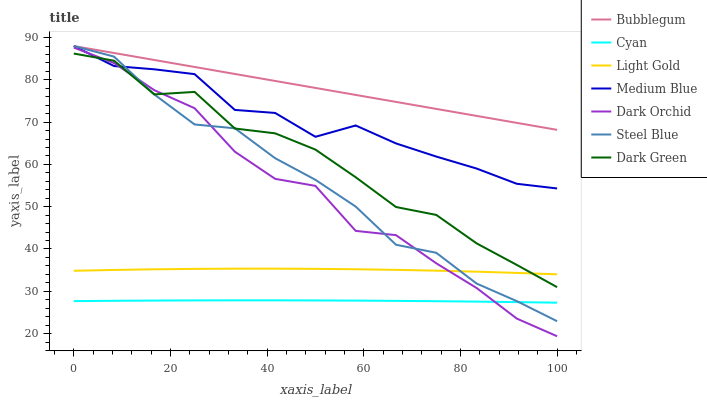Does Cyan have the minimum area under the curve?
Answer yes or no. Yes. Does Bubblegum have the maximum area under the curve?
Answer yes or no. Yes. Does Steel Blue have the minimum area under the curve?
Answer yes or no. No. Does Steel Blue have the maximum area under the curve?
Answer yes or no. No. Is Bubblegum the smoothest?
Answer yes or no. Yes. Is Dark Green the roughest?
Answer yes or no. Yes. Is Steel Blue the smoothest?
Answer yes or no. No. Is Steel Blue the roughest?
Answer yes or no. No. Does Dark Orchid have the lowest value?
Answer yes or no. Yes. Does Steel Blue have the lowest value?
Answer yes or no. No. Does Bubblegum have the highest value?
Answer yes or no. Yes. Does Dark Orchid have the highest value?
Answer yes or no. No. Is Cyan less than Bubblegum?
Answer yes or no. Yes. Is Light Gold greater than Cyan?
Answer yes or no. Yes. Does Medium Blue intersect Bubblegum?
Answer yes or no. Yes. Is Medium Blue less than Bubblegum?
Answer yes or no. No. Is Medium Blue greater than Bubblegum?
Answer yes or no. No. Does Cyan intersect Bubblegum?
Answer yes or no. No. 